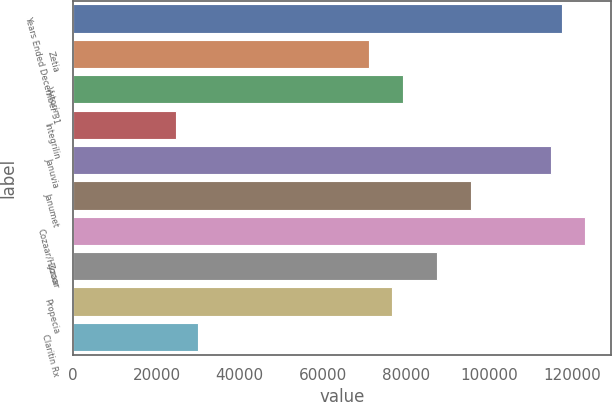Convert chart. <chart><loc_0><loc_0><loc_500><loc_500><bar_chart><fcel>Years Ended December 31<fcel>Zetia<fcel>Vytorin<fcel>Integrilin<fcel>Januvia<fcel>Janumet<fcel>Cozaar/Hyzaar<fcel>Zocor<fcel>Propecia<fcel>Claritin Rx<nl><fcel>117592<fcel>71103.6<fcel>79307.4<fcel>24615.4<fcel>114857<fcel>95715<fcel>123061<fcel>87511.2<fcel>76572.8<fcel>30084.6<nl></chart> 